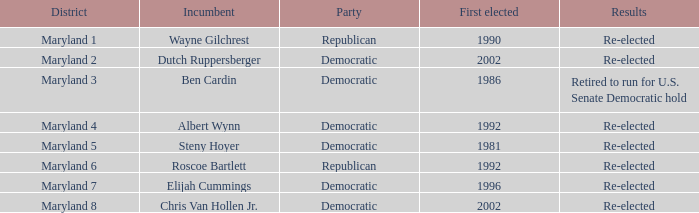What is the party of the maryland 6 district? Republican. Give me the full table as a dictionary. {'header': ['District', 'Incumbent', 'Party', 'First elected', 'Results'], 'rows': [['Maryland 1', 'Wayne Gilchrest', 'Republican', '1990', 'Re-elected'], ['Maryland 2', 'Dutch Ruppersberger', 'Democratic', '2002', 'Re-elected'], ['Maryland 3', 'Ben Cardin', 'Democratic', '1986', 'Retired to run for U.S. Senate Democratic hold'], ['Maryland 4', 'Albert Wynn', 'Democratic', '1992', 'Re-elected'], ['Maryland 5', 'Steny Hoyer', 'Democratic', '1981', 'Re-elected'], ['Maryland 6', 'Roscoe Bartlett', 'Republican', '1992', 'Re-elected'], ['Maryland 7', 'Elijah Cummings', 'Democratic', '1996', 'Re-elected'], ['Maryland 8', 'Chris Van Hollen Jr.', 'Democratic', '2002', 'Re-elected']]} 